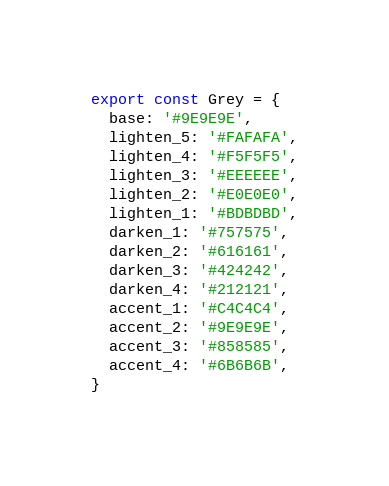Convert code to text. <code><loc_0><loc_0><loc_500><loc_500><_JavaScript_>export const Grey = {
  base: '#9E9E9E',
  lighten_5: '#FAFAFA',
  lighten_4: '#F5F5F5',
  lighten_3: '#EEEEEE',
  lighten_2: '#E0E0E0',
  lighten_1: '#BDBDBD',
  darken_1: '#757575',
  darken_2: '#616161',
  darken_3: '#424242',
  darken_4: '#212121',
  accent_1: '#C4C4C4',
  accent_2: '#9E9E9E',
  accent_3: '#858585',
  accent_4: '#6B6B6B',
}
</code> 